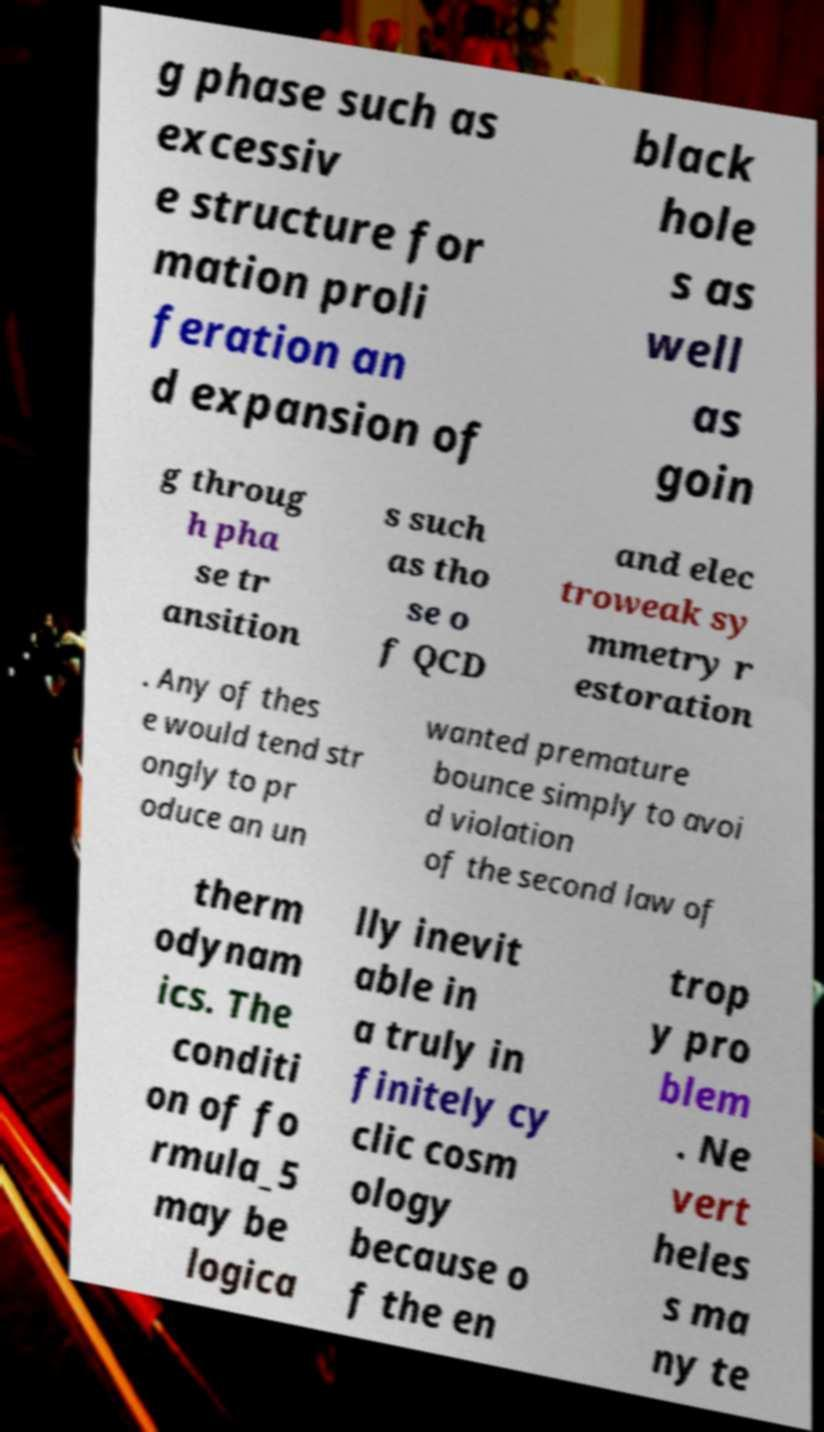What messages or text are displayed in this image? I need them in a readable, typed format. g phase such as excessiv e structure for mation proli feration an d expansion of black hole s as well as goin g throug h pha se tr ansition s such as tho se o f QCD and elec troweak sy mmetry r estoration . Any of thes e would tend str ongly to pr oduce an un wanted premature bounce simply to avoi d violation of the second law of therm odynam ics. The conditi on of fo rmula_5 may be logica lly inevit able in a truly in finitely cy clic cosm ology because o f the en trop y pro blem . Ne vert heles s ma ny te 